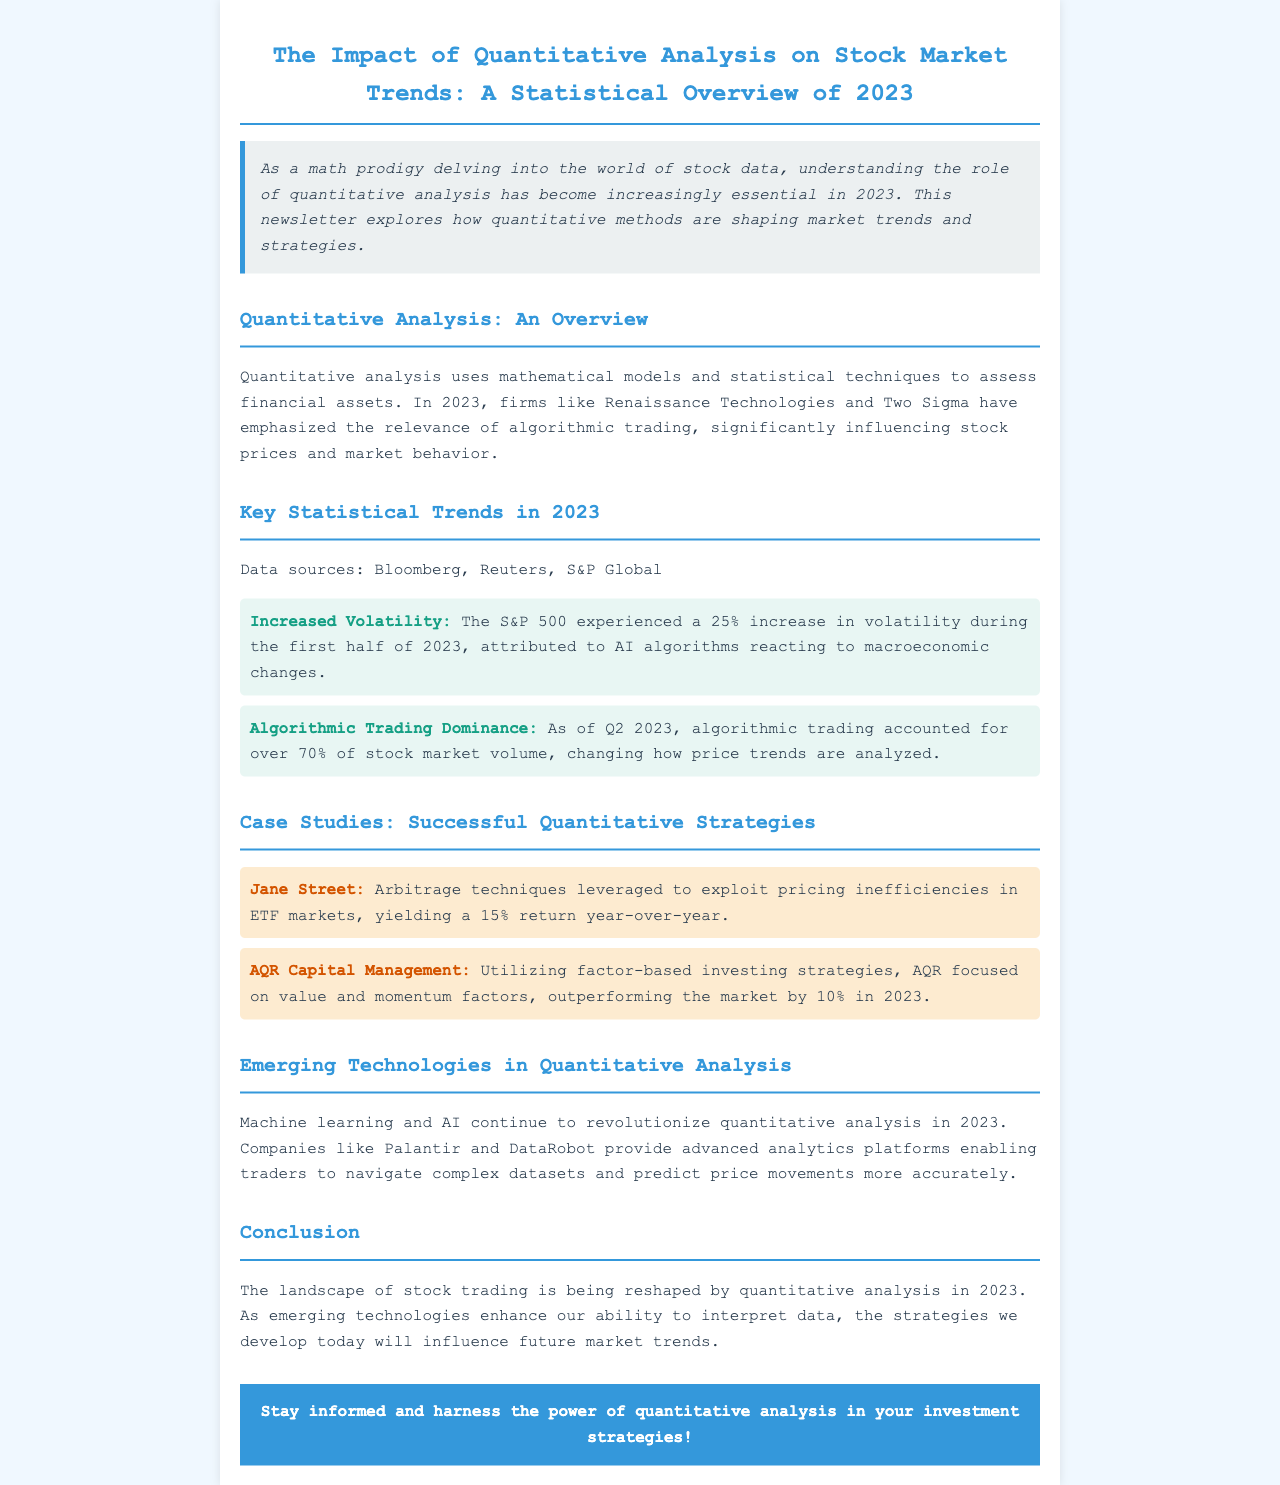What percentage increase in volatility did the S&P 500 experience in 2023? The document states that the S&P 500 experienced a 25% increase in volatility during the first half of 2023.
Answer: 25% What companies emphasized algorithmic trading in 2023? The document mentions Renaissance Technologies and Two Sigma as firms that have emphasized algorithmic trading.
Answer: Renaissance Technologies and Two Sigma What percentage of stock market volume was accounted for by algorithmic trading as of Q2 2023? The document indicates that algorithmic trading accounted for over 70% of stock market volume in Q2 2023.
Answer: Over 70% Which company utilized arbitrage techniques in 2023? The case study refers to Jane Street as a company that leveraged arbitrage techniques.
Answer: Jane Street By how much did AQR outperform the market in 2023? AQR Capital Management is noted to have outperformed the market by 10% in 2023.
Answer: 10% What type of analytics platforms are provided by companies like Palantir and DataRobot? The document states they provide advanced analytics platforms enabling traders to navigate complex datasets.
Answer: Advanced analytics platforms What is the primary influence of quantitative analysis on stock trading according to the conclusion? The conclusion mentions that quantitative analysis is reshaping the landscape of stock trading in 2023.
Answer: Reshaping the landscape What is the theme of the introduction in the newsletter? The introduction emphasizes the increasing essentiality of understanding quantitative analysis in 2023 for a math prodigy analyzing stock data.
Answer: Understanding the role of quantitative analysis Which statistical technique is primarily used in quantitative analysis? The document describes quantitative analysis as using mathematical models and statistical techniques.
Answer: Mathematical models and statistical techniques 